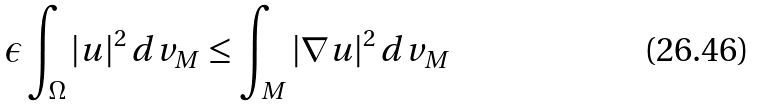<formula> <loc_0><loc_0><loc_500><loc_500>\epsilon \int _ { \Omega } | u | ^ { 2 } \, d v _ { M } \leq \int _ { M } | \nabla u | ^ { 2 } \, d v _ { M }</formula> 